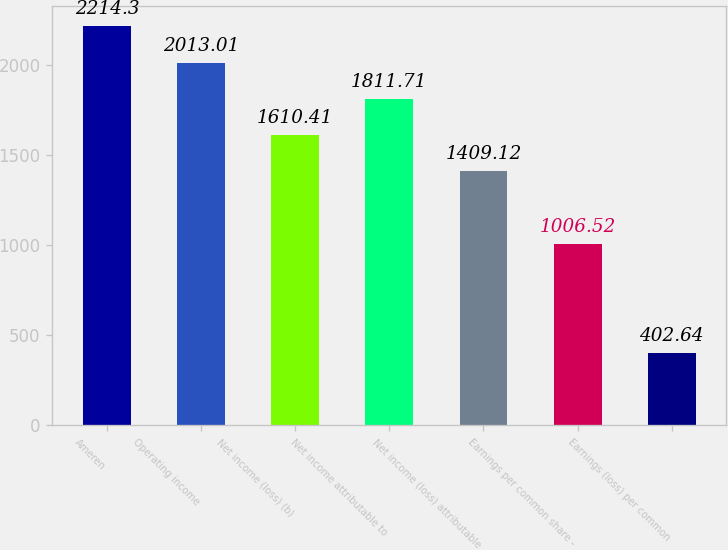<chart> <loc_0><loc_0><loc_500><loc_500><bar_chart><fcel>Ameren<fcel>Operating income<fcel>Net income (loss) (b)<fcel>Net income attributable to<fcel>Net income (loss) attributable<fcel>Earnings per common share -<fcel>Earnings (loss) per common<nl><fcel>2214.3<fcel>2013.01<fcel>1610.41<fcel>1811.71<fcel>1409.12<fcel>1006.52<fcel>402.64<nl></chart> 